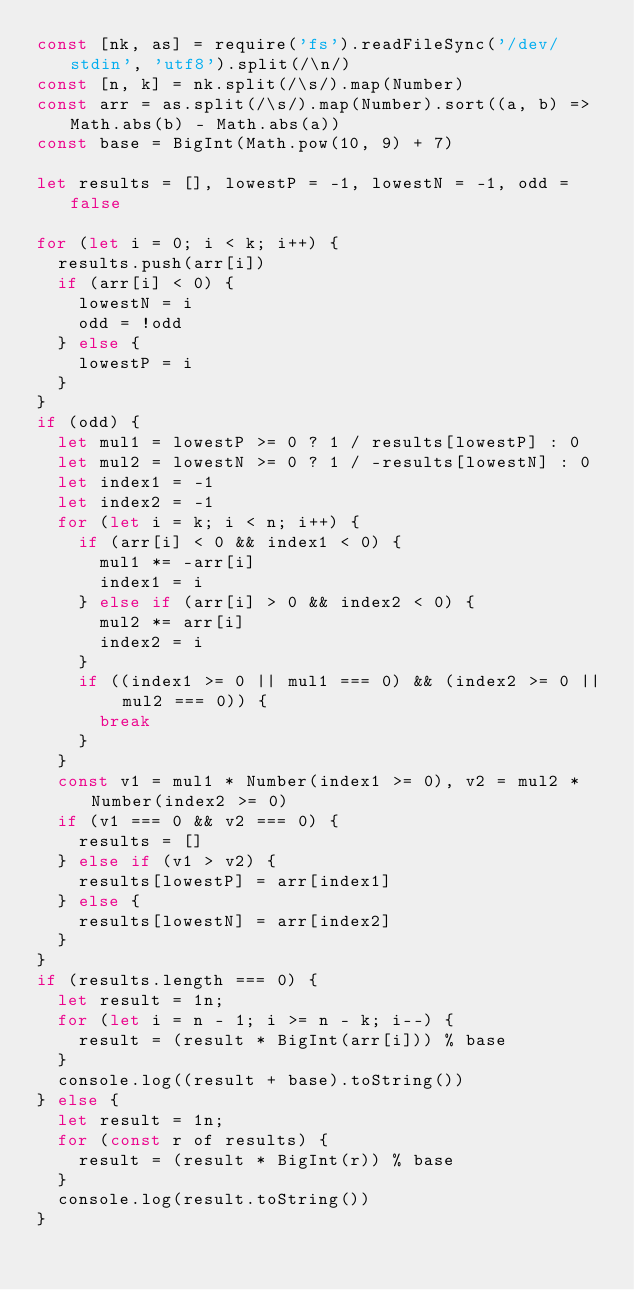Convert code to text. <code><loc_0><loc_0><loc_500><loc_500><_JavaScript_>const [nk, as] = require('fs').readFileSync('/dev/stdin', 'utf8').split(/\n/)
const [n, k] = nk.split(/\s/).map(Number)
const arr = as.split(/\s/).map(Number).sort((a, b) => Math.abs(b) - Math.abs(a))
const base = BigInt(Math.pow(10, 9) + 7)

let results = [], lowestP = -1, lowestN = -1, odd = false

for (let i = 0; i < k; i++) {
  results.push(arr[i])
  if (arr[i] < 0) {
    lowestN = i
    odd = !odd
  } else {
    lowestP = i
  }
}
if (odd) {
  let mul1 = lowestP >= 0 ? 1 / results[lowestP] : 0
  let mul2 = lowestN >= 0 ? 1 / -results[lowestN] : 0
  let index1 = -1
  let index2 = -1
  for (let i = k; i < n; i++) {
    if (arr[i] < 0 && index1 < 0) {
      mul1 *= -arr[i]
      index1 = i
    } else if (arr[i] > 0 && index2 < 0) {
      mul2 *= arr[i]
      index2 = i
    }
    if ((index1 >= 0 || mul1 === 0) && (index2 >= 0 || mul2 === 0)) {
      break
    }
  }
  const v1 = mul1 * Number(index1 >= 0), v2 = mul2 * Number(index2 >= 0)
  if (v1 === 0 && v2 === 0) {
    results = []
  } else if (v1 > v2) {
    results[lowestP] = arr[index1]
  } else {
    results[lowestN] = arr[index2]
  }
}
if (results.length === 0) {
  let result = 1n;
  for (let i = n - 1; i >= n - k; i--) {
    result = (result * BigInt(arr[i])) % base
  }
  console.log((result + base).toString())
} else {
  let result = 1n;
  for (const r of results) {
    result = (result * BigInt(r)) % base
  }
  console.log(result.toString())
}</code> 